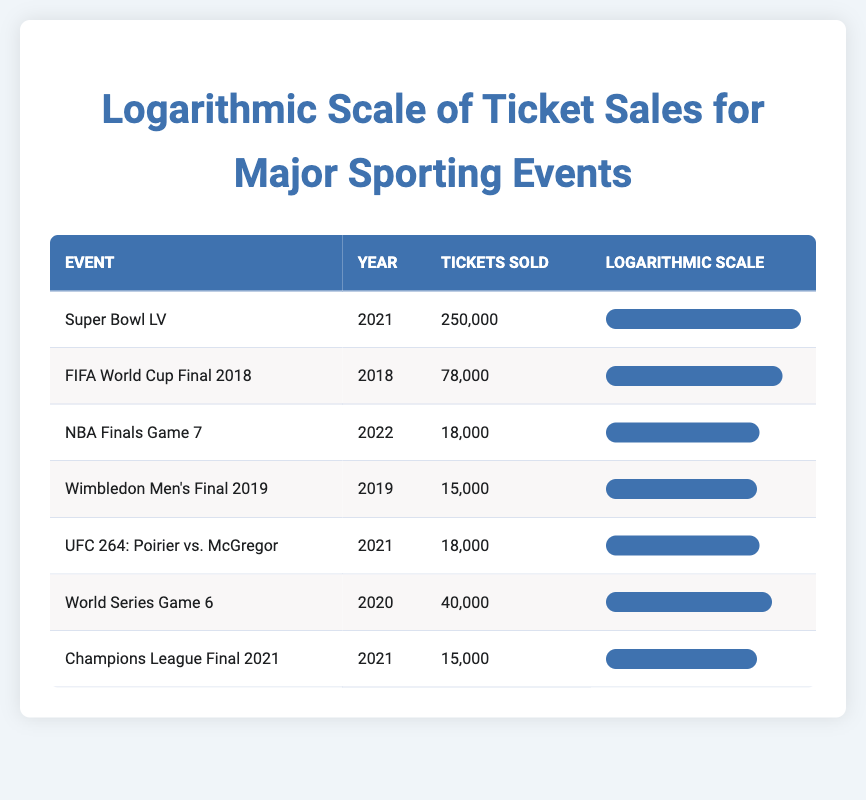What was the highest ticket sale event listed in the table? Super Bowl LV had the highest ticket sales at 250,000. You can directly find this value in the table under "Tickets Sold" in the row for the Super Bowl LV event.
Answer: 250,000 Which event had the lowest number of tickets sold? The event with the lowest tickets sold was Champions League Final 2021 with 15,000 tickets. This value can be seen in the respective row of the table.
Answer: 15,000 How many total tickets were sold across all events in 2021? To find the total tickets sold in 2021, we sum the tickets sold for Super Bowl LV (250,000), UFC 264 (18,000), and Champions League Final (15,000): 250,000 + 18,000 + 15,000 = 283,000.
Answer: 283,000 Is it true that the NBA Finals Game 7 sold more tickets than the World Series Game 6? No, it is false. NBA Finals Game 7 sold 18,000 tickets, while World Series Game 6 sold 40,000 tickets. Both values can be found directly in their respective rows.
Answer: No What is the average number of tickets sold across all events? First, we sum all the tickets sold: 250,000 + 78,000 + 18,000 + 15,000 + 18,000 + 40,000 + 15,000 = 419,000. There are 7 events, so we divide the total by 7: 419,000 / 7 = 59,857.14. Rounding gives us approximately 59,857 tickets on average.
Answer: 59,857 Which event had a similar number of tickets sold as the Wimbledon Men's Final 2019? The NCAA Championships (under UFC 264: Poirier vs. McGregor and NBA Finals Game 7) both had similar ticket sales of 18,000 tickets, which is close to the 15,000 tickets sold for Wimbledon Men's Final 2019. You can compare the values in the table to find this resemblance.
Answer: 18,000 How does the ticket sale for FIFA World Cup Final 2018 compare with that of the Super Bowl LV? The FIFA World Cup Final 2018 sold 78,000 tickets, which is significantly lower than Super Bowl LV's 250,000 tickets. The specific values are listed in their respective table rows, clearly showing that the Super Bowl LV had a much higher ticket sale.
Answer: Lower What percentage of tickets were sold for the UFC 264 compared to the Super Bowl LV? To find the percentage, we use the formula: (tickets sold for UFC 264 / tickets sold for Super Bowl LV) * 100. This is calculated as (18,000 / 250,000) * 100 = 7.2%. Thus, UFC 264 sold 7.2% of the tickets compared to Super Bowl LV.
Answer: 7.2% 